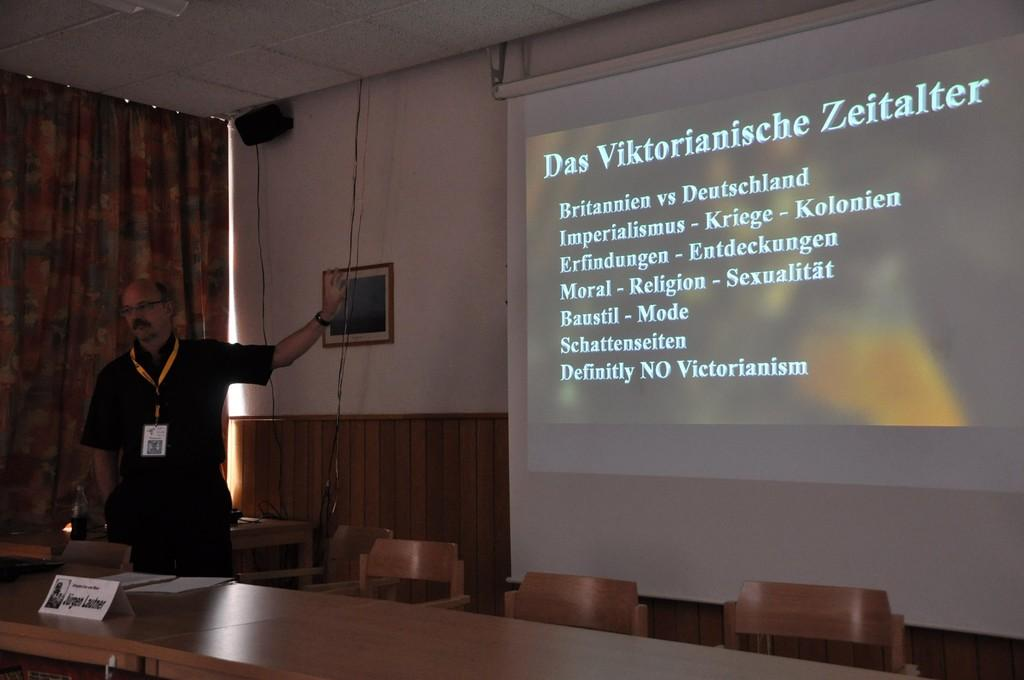What is the main subject in the image? There is a man standing in the image. What is the purpose of the projector screen in the image? The projector screen is likely used for presentations or displaying visuals. What furniture is present in the image? There is a table and chairs in the image. What can be seen on the wall in the image? There is a photo frame on the wall in the image. What type of brick is used to build the wall in the image? There is no mention of a brick wall in the image; it only features a photo frame on the wall. How old is the boy in the image? There is no boy present in the image; it features a man standing. 